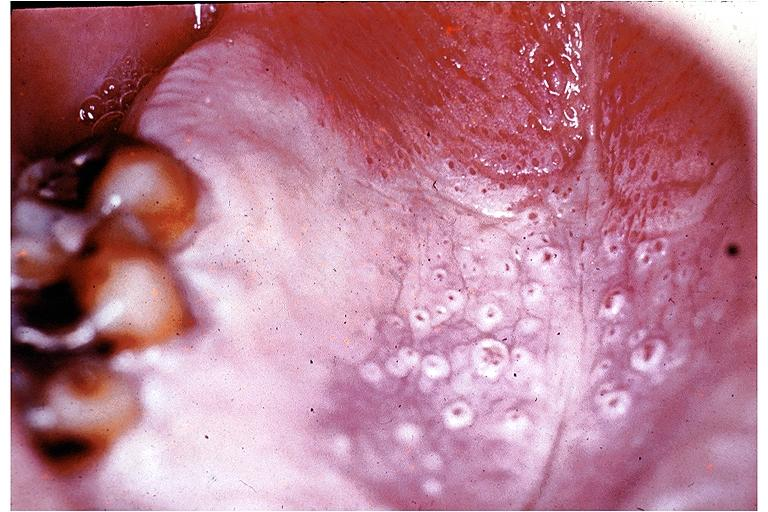does close-up tumor show nicotine stomatitis?
Answer the question using a single word or phrase. No 